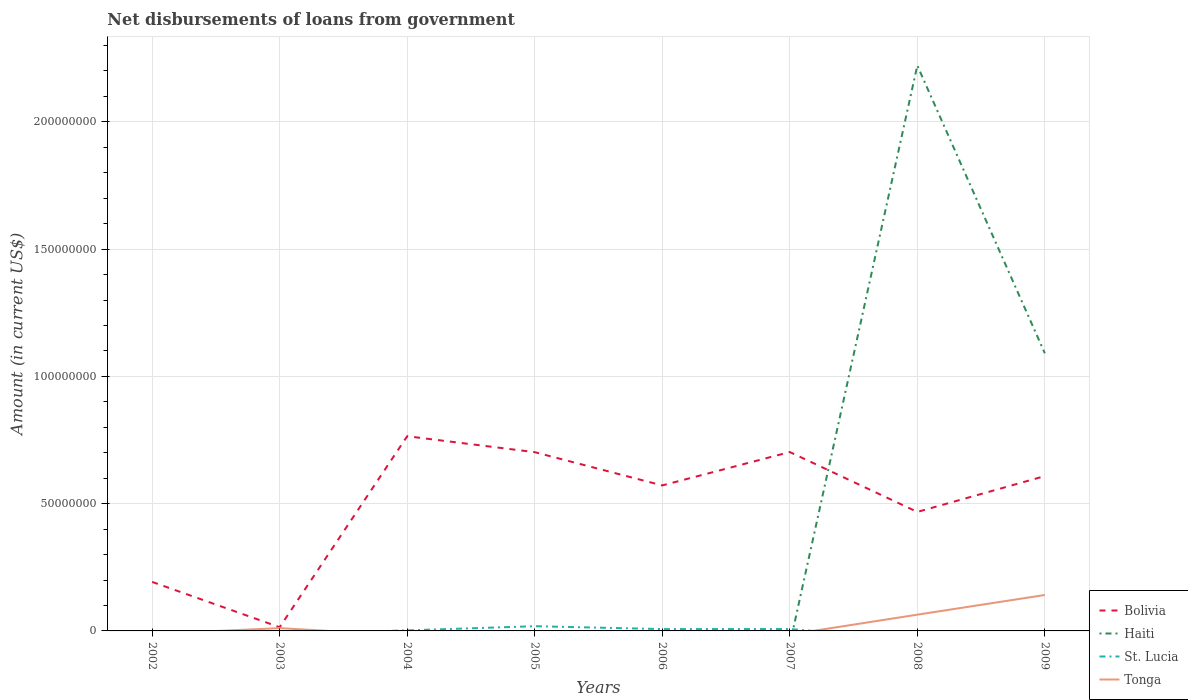Does the line corresponding to St. Lucia intersect with the line corresponding to Bolivia?
Ensure brevity in your answer.  No. Is the number of lines equal to the number of legend labels?
Ensure brevity in your answer.  No. What is the total amount of loan disbursed from government in Bolivia in the graph?
Your answer should be very brief. -6.88e+07. What is the difference between the highest and the second highest amount of loan disbursed from government in St. Lucia?
Offer a very short reply. 1.85e+06. Is the amount of loan disbursed from government in St. Lucia strictly greater than the amount of loan disbursed from government in Tonga over the years?
Your answer should be compact. No. How many lines are there?
Offer a terse response. 4. How many years are there in the graph?
Offer a very short reply. 8. Are the values on the major ticks of Y-axis written in scientific E-notation?
Offer a terse response. No. Where does the legend appear in the graph?
Your response must be concise. Bottom right. What is the title of the graph?
Offer a very short reply. Net disbursements of loans from government. What is the label or title of the X-axis?
Ensure brevity in your answer.  Years. What is the label or title of the Y-axis?
Your answer should be compact. Amount (in current US$). What is the Amount (in current US$) of Bolivia in 2002?
Your response must be concise. 1.93e+07. What is the Amount (in current US$) in Haiti in 2002?
Your answer should be compact. 0. What is the Amount (in current US$) in St. Lucia in 2002?
Offer a terse response. 0. What is the Amount (in current US$) of Tonga in 2002?
Offer a very short reply. 0. What is the Amount (in current US$) of Bolivia in 2003?
Ensure brevity in your answer.  1.46e+06. What is the Amount (in current US$) of Haiti in 2003?
Ensure brevity in your answer.  0. What is the Amount (in current US$) of St. Lucia in 2003?
Offer a very short reply. 0. What is the Amount (in current US$) of Tonga in 2003?
Provide a short and direct response. 1.09e+06. What is the Amount (in current US$) of Bolivia in 2004?
Provide a short and direct response. 7.65e+07. What is the Amount (in current US$) of Haiti in 2004?
Give a very brief answer. 0. What is the Amount (in current US$) of St. Lucia in 2004?
Keep it short and to the point. 2.13e+05. What is the Amount (in current US$) in Bolivia in 2005?
Offer a terse response. 7.02e+07. What is the Amount (in current US$) in Haiti in 2005?
Keep it short and to the point. 0. What is the Amount (in current US$) of St. Lucia in 2005?
Give a very brief answer. 1.85e+06. What is the Amount (in current US$) of Bolivia in 2006?
Give a very brief answer. 5.72e+07. What is the Amount (in current US$) of St. Lucia in 2006?
Your answer should be compact. 7.25e+05. What is the Amount (in current US$) of Tonga in 2006?
Ensure brevity in your answer.  0. What is the Amount (in current US$) in Bolivia in 2007?
Your answer should be very brief. 7.03e+07. What is the Amount (in current US$) of St. Lucia in 2007?
Provide a succinct answer. 7.51e+05. What is the Amount (in current US$) of Bolivia in 2008?
Give a very brief answer. 4.68e+07. What is the Amount (in current US$) in Haiti in 2008?
Offer a terse response. 2.22e+08. What is the Amount (in current US$) of St. Lucia in 2008?
Keep it short and to the point. 0. What is the Amount (in current US$) in Tonga in 2008?
Provide a succinct answer. 6.39e+06. What is the Amount (in current US$) in Bolivia in 2009?
Your answer should be compact. 6.08e+07. What is the Amount (in current US$) of Haiti in 2009?
Provide a short and direct response. 1.09e+08. What is the Amount (in current US$) in Tonga in 2009?
Provide a succinct answer. 1.41e+07. Across all years, what is the maximum Amount (in current US$) in Bolivia?
Ensure brevity in your answer.  7.65e+07. Across all years, what is the maximum Amount (in current US$) of Haiti?
Provide a short and direct response. 2.22e+08. Across all years, what is the maximum Amount (in current US$) in St. Lucia?
Keep it short and to the point. 1.85e+06. Across all years, what is the maximum Amount (in current US$) in Tonga?
Keep it short and to the point. 1.41e+07. Across all years, what is the minimum Amount (in current US$) of Bolivia?
Your answer should be compact. 1.46e+06. Across all years, what is the minimum Amount (in current US$) of St. Lucia?
Ensure brevity in your answer.  0. Across all years, what is the minimum Amount (in current US$) of Tonga?
Provide a short and direct response. 0. What is the total Amount (in current US$) in Bolivia in the graph?
Your answer should be very brief. 4.02e+08. What is the total Amount (in current US$) in Haiti in the graph?
Provide a short and direct response. 3.31e+08. What is the total Amount (in current US$) of St. Lucia in the graph?
Ensure brevity in your answer.  3.54e+06. What is the total Amount (in current US$) of Tonga in the graph?
Your answer should be compact. 2.16e+07. What is the difference between the Amount (in current US$) of Bolivia in 2002 and that in 2003?
Your response must be concise. 1.78e+07. What is the difference between the Amount (in current US$) of Bolivia in 2002 and that in 2004?
Make the answer very short. -5.72e+07. What is the difference between the Amount (in current US$) of Bolivia in 2002 and that in 2005?
Provide a succinct answer. -5.10e+07. What is the difference between the Amount (in current US$) of Bolivia in 2002 and that in 2006?
Provide a short and direct response. -3.79e+07. What is the difference between the Amount (in current US$) of Bolivia in 2002 and that in 2007?
Provide a succinct answer. -5.10e+07. What is the difference between the Amount (in current US$) in Bolivia in 2002 and that in 2008?
Keep it short and to the point. -2.75e+07. What is the difference between the Amount (in current US$) in Bolivia in 2002 and that in 2009?
Provide a succinct answer. -4.16e+07. What is the difference between the Amount (in current US$) in Bolivia in 2003 and that in 2004?
Ensure brevity in your answer.  -7.50e+07. What is the difference between the Amount (in current US$) in Bolivia in 2003 and that in 2005?
Your answer should be very brief. -6.88e+07. What is the difference between the Amount (in current US$) of Bolivia in 2003 and that in 2006?
Ensure brevity in your answer.  -5.57e+07. What is the difference between the Amount (in current US$) of Bolivia in 2003 and that in 2007?
Give a very brief answer. -6.88e+07. What is the difference between the Amount (in current US$) in Bolivia in 2003 and that in 2008?
Your response must be concise. -4.53e+07. What is the difference between the Amount (in current US$) in Tonga in 2003 and that in 2008?
Provide a succinct answer. -5.30e+06. What is the difference between the Amount (in current US$) in Bolivia in 2003 and that in 2009?
Provide a succinct answer. -5.94e+07. What is the difference between the Amount (in current US$) of Tonga in 2003 and that in 2009?
Make the answer very short. -1.30e+07. What is the difference between the Amount (in current US$) of Bolivia in 2004 and that in 2005?
Make the answer very short. 6.26e+06. What is the difference between the Amount (in current US$) of St. Lucia in 2004 and that in 2005?
Your answer should be compact. -1.64e+06. What is the difference between the Amount (in current US$) in Bolivia in 2004 and that in 2006?
Your response must be concise. 1.93e+07. What is the difference between the Amount (in current US$) in St. Lucia in 2004 and that in 2006?
Give a very brief answer. -5.12e+05. What is the difference between the Amount (in current US$) in Bolivia in 2004 and that in 2007?
Your response must be concise. 6.22e+06. What is the difference between the Amount (in current US$) of St. Lucia in 2004 and that in 2007?
Your answer should be compact. -5.38e+05. What is the difference between the Amount (in current US$) in Bolivia in 2004 and that in 2008?
Your answer should be compact. 2.97e+07. What is the difference between the Amount (in current US$) in Bolivia in 2004 and that in 2009?
Give a very brief answer. 1.57e+07. What is the difference between the Amount (in current US$) in Bolivia in 2005 and that in 2006?
Provide a succinct answer. 1.31e+07. What is the difference between the Amount (in current US$) of St. Lucia in 2005 and that in 2006?
Your response must be concise. 1.13e+06. What is the difference between the Amount (in current US$) of Bolivia in 2005 and that in 2007?
Provide a short and direct response. -4.80e+04. What is the difference between the Amount (in current US$) in St. Lucia in 2005 and that in 2007?
Offer a very short reply. 1.10e+06. What is the difference between the Amount (in current US$) in Bolivia in 2005 and that in 2008?
Your response must be concise. 2.35e+07. What is the difference between the Amount (in current US$) of Bolivia in 2005 and that in 2009?
Ensure brevity in your answer.  9.39e+06. What is the difference between the Amount (in current US$) in Bolivia in 2006 and that in 2007?
Give a very brief answer. -1.31e+07. What is the difference between the Amount (in current US$) of St. Lucia in 2006 and that in 2007?
Keep it short and to the point. -2.60e+04. What is the difference between the Amount (in current US$) in Bolivia in 2006 and that in 2008?
Offer a terse response. 1.04e+07. What is the difference between the Amount (in current US$) of Bolivia in 2006 and that in 2009?
Keep it short and to the point. -3.67e+06. What is the difference between the Amount (in current US$) of Bolivia in 2007 and that in 2008?
Make the answer very short. 2.35e+07. What is the difference between the Amount (in current US$) in Bolivia in 2007 and that in 2009?
Give a very brief answer. 9.44e+06. What is the difference between the Amount (in current US$) of Bolivia in 2008 and that in 2009?
Give a very brief answer. -1.41e+07. What is the difference between the Amount (in current US$) in Haiti in 2008 and that in 2009?
Your response must be concise. 1.13e+08. What is the difference between the Amount (in current US$) of Tonga in 2008 and that in 2009?
Offer a terse response. -7.73e+06. What is the difference between the Amount (in current US$) of Bolivia in 2002 and the Amount (in current US$) of Tonga in 2003?
Offer a very short reply. 1.82e+07. What is the difference between the Amount (in current US$) of Bolivia in 2002 and the Amount (in current US$) of St. Lucia in 2004?
Provide a succinct answer. 1.90e+07. What is the difference between the Amount (in current US$) of Bolivia in 2002 and the Amount (in current US$) of St. Lucia in 2005?
Your response must be concise. 1.74e+07. What is the difference between the Amount (in current US$) of Bolivia in 2002 and the Amount (in current US$) of St. Lucia in 2006?
Make the answer very short. 1.85e+07. What is the difference between the Amount (in current US$) of Bolivia in 2002 and the Amount (in current US$) of St. Lucia in 2007?
Keep it short and to the point. 1.85e+07. What is the difference between the Amount (in current US$) of Bolivia in 2002 and the Amount (in current US$) of Haiti in 2008?
Keep it short and to the point. -2.03e+08. What is the difference between the Amount (in current US$) of Bolivia in 2002 and the Amount (in current US$) of Tonga in 2008?
Provide a short and direct response. 1.29e+07. What is the difference between the Amount (in current US$) of Bolivia in 2002 and the Amount (in current US$) of Haiti in 2009?
Offer a very short reply. -8.98e+07. What is the difference between the Amount (in current US$) in Bolivia in 2002 and the Amount (in current US$) in Tonga in 2009?
Keep it short and to the point. 5.14e+06. What is the difference between the Amount (in current US$) in Bolivia in 2003 and the Amount (in current US$) in St. Lucia in 2004?
Provide a succinct answer. 1.24e+06. What is the difference between the Amount (in current US$) of Bolivia in 2003 and the Amount (in current US$) of St. Lucia in 2005?
Offer a very short reply. -3.97e+05. What is the difference between the Amount (in current US$) of Bolivia in 2003 and the Amount (in current US$) of St. Lucia in 2006?
Keep it short and to the point. 7.31e+05. What is the difference between the Amount (in current US$) in Bolivia in 2003 and the Amount (in current US$) in St. Lucia in 2007?
Your response must be concise. 7.05e+05. What is the difference between the Amount (in current US$) of Bolivia in 2003 and the Amount (in current US$) of Haiti in 2008?
Offer a very short reply. -2.21e+08. What is the difference between the Amount (in current US$) of Bolivia in 2003 and the Amount (in current US$) of Tonga in 2008?
Make the answer very short. -4.93e+06. What is the difference between the Amount (in current US$) of Bolivia in 2003 and the Amount (in current US$) of Haiti in 2009?
Offer a very short reply. -1.08e+08. What is the difference between the Amount (in current US$) of Bolivia in 2003 and the Amount (in current US$) of Tonga in 2009?
Provide a short and direct response. -1.27e+07. What is the difference between the Amount (in current US$) of Bolivia in 2004 and the Amount (in current US$) of St. Lucia in 2005?
Offer a very short reply. 7.46e+07. What is the difference between the Amount (in current US$) in Bolivia in 2004 and the Amount (in current US$) in St. Lucia in 2006?
Ensure brevity in your answer.  7.58e+07. What is the difference between the Amount (in current US$) in Bolivia in 2004 and the Amount (in current US$) in St. Lucia in 2007?
Your answer should be very brief. 7.57e+07. What is the difference between the Amount (in current US$) in Bolivia in 2004 and the Amount (in current US$) in Haiti in 2008?
Give a very brief answer. -1.46e+08. What is the difference between the Amount (in current US$) of Bolivia in 2004 and the Amount (in current US$) of Tonga in 2008?
Your answer should be compact. 7.01e+07. What is the difference between the Amount (in current US$) in St. Lucia in 2004 and the Amount (in current US$) in Tonga in 2008?
Make the answer very short. -6.17e+06. What is the difference between the Amount (in current US$) in Bolivia in 2004 and the Amount (in current US$) in Haiti in 2009?
Give a very brief answer. -3.26e+07. What is the difference between the Amount (in current US$) of Bolivia in 2004 and the Amount (in current US$) of Tonga in 2009?
Your answer should be compact. 6.24e+07. What is the difference between the Amount (in current US$) of St. Lucia in 2004 and the Amount (in current US$) of Tonga in 2009?
Ensure brevity in your answer.  -1.39e+07. What is the difference between the Amount (in current US$) of Bolivia in 2005 and the Amount (in current US$) of St. Lucia in 2006?
Your answer should be very brief. 6.95e+07. What is the difference between the Amount (in current US$) of Bolivia in 2005 and the Amount (in current US$) of St. Lucia in 2007?
Provide a short and direct response. 6.95e+07. What is the difference between the Amount (in current US$) of Bolivia in 2005 and the Amount (in current US$) of Haiti in 2008?
Provide a short and direct response. -1.52e+08. What is the difference between the Amount (in current US$) of Bolivia in 2005 and the Amount (in current US$) of Tonga in 2008?
Make the answer very short. 6.38e+07. What is the difference between the Amount (in current US$) in St. Lucia in 2005 and the Amount (in current US$) in Tonga in 2008?
Offer a terse response. -4.53e+06. What is the difference between the Amount (in current US$) in Bolivia in 2005 and the Amount (in current US$) in Haiti in 2009?
Your response must be concise. -3.88e+07. What is the difference between the Amount (in current US$) in Bolivia in 2005 and the Amount (in current US$) in Tonga in 2009?
Make the answer very short. 5.61e+07. What is the difference between the Amount (in current US$) in St. Lucia in 2005 and the Amount (in current US$) in Tonga in 2009?
Offer a very short reply. -1.23e+07. What is the difference between the Amount (in current US$) in Bolivia in 2006 and the Amount (in current US$) in St. Lucia in 2007?
Keep it short and to the point. 5.64e+07. What is the difference between the Amount (in current US$) in Bolivia in 2006 and the Amount (in current US$) in Haiti in 2008?
Your answer should be compact. -1.65e+08. What is the difference between the Amount (in current US$) in Bolivia in 2006 and the Amount (in current US$) in Tonga in 2008?
Make the answer very short. 5.08e+07. What is the difference between the Amount (in current US$) of St. Lucia in 2006 and the Amount (in current US$) of Tonga in 2008?
Keep it short and to the point. -5.66e+06. What is the difference between the Amount (in current US$) of Bolivia in 2006 and the Amount (in current US$) of Haiti in 2009?
Keep it short and to the point. -5.19e+07. What is the difference between the Amount (in current US$) of Bolivia in 2006 and the Amount (in current US$) of Tonga in 2009?
Give a very brief answer. 4.30e+07. What is the difference between the Amount (in current US$) in St. Lucia in 2006 and the Amount (in current US$) in Tonga in 2009?
Ensure brevity in your answer.  -1.34e+07. What is the difference between the Amount (in current US$) in Bolivia in 2007 and the Amount (in current US$) in Haiti in 2008?
Your response must be concise. -1.52e+08. What is the difference between the Amount (in current US$) in Bolivia in 2007 and the Amount (in current US$) in Tonga in 2008?
Offer a terse response. 6.39e+07. What is the difference between the Amount (in current US$) of St. Lucia in 2007 and the Amount (in current US$) of Tonga in 2008?
Offer a terse response. -5.64e+06. What is the difference between the Amount (in current US$) in Bolivia in 2007 and the Amount (in current US$) in Haiti in 2009?
Make the answer very short. -3.88e+07. What is the difference between the Amount (in current US$) in Bolivia in 2007 and the Amount (in current US$) in Tonga in 2009?
Your response must be concise. 5.62e+07. What is the difference between the Amount (in current US$) in St. Lucia in 2007 and the Amount (in current US$) in Tonga in 2009?
Give a very brief answer. -1.34e+07. What is the difference between the Amount (in current US$) of Bolivia in 2008 and the Amount (in current US$) of Haiti in 2009?
Your answer should be very brief. -6.23e+07. What is the difference between the Amount (in current US$) of Bolivia in 2008 and the Amount (in current US$) of Tonga in 2009?
Offer a terse response. 3.26e+07. What is the difference between the Amount (in current US$) of Haiti in 2008 and the Amount (in current US$) of Tonga in 2009?
Give a very brief answer. 2.08e+08. What is the average Amount (in current US$) of Bolivia per year?
Give a very brief answer. 5.03e+07. What is the average Amount (in current US$) in Haiti per year?
Provide a short and direct response. 4.14e+07. What is the average Amount (in current US$) in St. Lucia per year?
Your response must be concise. 4.43e+05. What is the average Amount (in current US$) of Tonga per year?
Your response must be concise. 2.70e+06. In the year 2003, what is the difference between the Amount (in current US$) of Bolivia and Amount (in current US$) of Tonga?
Make the answer very short. 3.66e+05. In the year 2004, what is the difference between the Amount (in current US$) of Bolivia and Amount (in current US$) of St. Lucia?
Provide a succinct answer. 7.63e+07. In the year 2005, what is the difference between the Amount (in current US$) in Bolivia and Amount (in current US$) in St. Lucia?
Provide a short and direct response. 6.84e+07. In the year 2006, what is the difference between the Amount (in current US$) of Bolivia and Amount (in current US$) of St. Lucia?
Offer a very short reply. 5.64e+07. In the year 2007, what is the difference between the Amount (in current US$) of Bolivia and Amount (in current US$) of St. Lucia?
Provide a short and direct response. 6.95e+07. In the year 2008, what is the difference between the Amount (in current US$) of Bolivia and Amount (in current US$) of Haiti?
Make the answer very short. -1.75e+08. In the year 2008, what is the difference between the Amount (in current US$) in Bolivia and Amount (in current US$) in Tonga?
Offer a very short reply. 4.04e+07. In the year 2008, what is the difference between the Amount (in current US$) in Haiti and Amount (in current US$) in Tonga?
Offer a terse response. 2.16e+08. In the year 2009, what is the difference between the Amount (in current US$) of Bolivia and Amount (in current US$) of Haiti?
Keep it short and to the point. -4.82e+07. In the year 2009, what is the difference between the Amount (in current US$) of Bolivia and Amount (in current US$) of Tonga?
Provide a succinct answer. 4.67e+07. In the year 2009, what is the difference between the Amount (in current US$) of Haiti and Amount (in current US$) of Tonga?
Ensure brevity in your answer.  9.50e+07. What is the ratio of the Amount (in current US$) in Bolivia in 2002 to that in 2003?
Your answer should be very brief. 13.23. What is the ratio of the Amount (in current US$) in Bolivia in 2002 to that in 2004?
Your answer should be compact. 0.25. What is the ratio of the Amount (in current US$) in Bolivia in 2002 to that in 2005?
Give a very brief answer. 0.27. What is the ratio of the Amount (in current US$) of Bolivia in 2002 to that in 2006?
Ensure brevity in your answer.  0.34. What is the ratio of the Amount (in current US$) in Bolivia in 2002 to that in 2007?
Your response must be concise. 0.27. What is the ratio of the Amount (in current US$) in Bolivia in 2002 to that in 2008?
Offer a terse response. 0.41. What is the ratio of the Amount (in current US$) of Bolivia in 2002 to that in 2009?
Your answer should be very brief. 0.32. What is the ratio of the Amount (in current US$) in Bolivia in 2003 to that in 2004?
Give a very brief answer. 0.02. What is the ratio of the Amount (in current US$) in Bolivia in 2003 to that in 2005?
Make the answer very short. 0.02. What is the ratio of the Amount (in current US$) in Bolivia in 2003 to that in 2006?
Keep it short and to the point. 0.03. What is the ratio of the Amount (in current US$) of Bolivia in 2003 to that in 2007?
Your answer should be compact. 0.02. What is the ratio of the Amount (in current US$) in Bolivia in 2003 to that in 2008?
Make the answer very short. 0.03. What is the ratio of the Amount (in current US$) of Tonga in 2003 to that in 2008?
Make the answer very short. 0.17. What is the ratio of the Amount (in current US$) of Bolivia in 2003 to that in 2009?
Keep it short and to the point. 0.02. What is the ratio of the Amount (in current US$) of Tonga in 2003 to that in 2009?
Your answer should be compact. 0.08. What is the ratio of the Amount (in current US$) in Bolivia in 2004 to that in 2005?
Ensure brevity in your answer.  1.09. What is the ratio of the Amount (in current US$) in St. Lucia in 2004 to that in 2005?
Offer a terse response. 0.11. What is the ratio of the Amount (in current US$) in Bolivia in 2004 to that in 2006?
Make the answer very short. 1.34. What is the ratio of the Amount (in current US$) in St. Lucia in 2004 to that in 2006?
Your answer should be very brief. 0.29. What is the ratio of the Amount (in current US$) in Bolivia in 2004 to that in 2007?
Provide a short and direct response. 1.09. What is the ratio of the Amount (in current US$) of St. Lucia in 2004 to that in 2007?
Your answer should be compact. 0.28. What is the ratio of the Amount (in current US$) in Bolivia in 2004 to that in 2008?
Offer a terse response. 1.64. What is the ratio of the Amount (in current US$) of Bolivia in 2004 to that in 2009?
Provide a succinct answer. 1.26. What is the ratio of the Amount (in current US$) of Bolivia in 2005 to that in 2006?
Ensure brevity in your answer.  1.23. What is the ratio of the Amount (in current US$) in St. Lucia in 2005 to that in 2006?
Offer a very short reply. 2.56. What is the ratio of the Amount (in current US$) in Bolivia in 2005 to that in 2007?
Your response must be concise. 1. What is the ratio of the Amount (in current US$) of St. Lucia in 2005 to that in 2007?
Keep it short and to the point. 2.47. What is the ratio of the Amount (in current US$) in Bolivia in 2005 to that in 2008?
Offer a terse response. 1.5. What is the ratio of the Amount (in current US$) of Bolivia in 2005 to that in 2009?
Offer a terse response. 1.15. What is the ratio of the Amount (in current US$) of Bolivia in 2006 to that in 2007?
Give a very brief answer. 0.81. What is the ratio of the Amount (in current US$) of St. Lucia in 2006 to that in 2007?
Provide a short and direct response. 0.97. What is the ratio of the Amount (in current US$) of Bolivia in 2006 to that in 2008?
Offer a terse response. 1.22. What is the ratio of the Amount (in current US$) of Bolivia in 2006 to that in 2009?
Make the answer very short. 0.94. What is the ratio of the Amount (in current US$) in Bolivia in 2007 to that in 2008?
Provide a succinct answer. 1.5. What is the ratio of the Amount (in current US$) in Bolivia in 2007 to that in 2009?
Ensure brevity in your answer.  1.16. What is the ratio of the Amount (in current US$) of Bolivia in 2008 to that in 2009?
Provide a short and direct response. 0.77. What is the ratio of the Amount (in current US$) of Haiti in 2008 to that in 2009?
Offer a very short reply. 2.04. What is the ratio of the Amount (in current US$) of Tonga in 2008 to that in 2009?
Provide a succinct answer. 0.45. What is the difference between the highest and the second highest Amount (in current US$) of Bolivia?
Give a very brief answer. 6.22e+06. What is the difference between the highest and the second highest Amount (in current US$) in St. Lucia?
Your answer should be compact. 1.10e+06. What is the difference between the highest and the second highest Amount (in current US$) of Tonga?
Your answer should be compact. 7.73e+06. What is the difference between the highest and the lowest Amount (in current US$) in Bolivia?
Provide a short and direct response. 7.50e+07. What is the difference between the highest and the lowest Amount (in current US$) in Haiti?
Your answer should be compact. 2.22e+08. What is the difference between the highest and the lowest Amount (in current US$) of St. Lucia?
Give a very brief answer. 1.85e+06. What is the difference between the highest and the lowest Amount (in current US$) of Tonga?
Make the answer very short. 1.41e+07. 